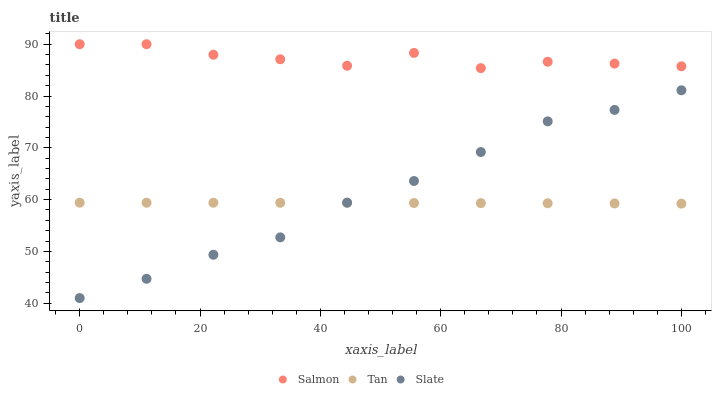Does Tan have the minimum area under the curve?
Answer yes or no. Yes. Does Salmon have the maximum area under the curve?
Answer yes or no. Yes. Does Slate have the minimum area under the curve?
Answer yes or no. No. Does Slate have the maximum area under the curve?
Answer yes or no. No. Is Tan the smoothest?
Answer yes or no. Yes. Is Salmon the roughest?
Answer yes or no. Yes. Is Slate the smoothest?
Answer yes or no. No. Is Slate the roughest?
Answer yes or no. No. Does Slate have the lowest value?
Answer yes or no. Yes. Does Salmon have the lowest value?
Answer yes or no. No. Does Salmon have the highest value?
Answer yes or no. Yes. Does Slate have the highest value?
Answer yes or no. No. Is Tan less than Salmon?
Answer yes or no. Yes. Is Salmon greater than Slate?
Answer yes or no. Yes. Does Tan intersect Slate?
Answer yes or no. Yes. Is Tan less than Slate?
Answer yes or no. No. Is Tan greater than Slate?
Answer yes or no. No. Does Tan intersect Salmon?
Answer yes or no. No. 